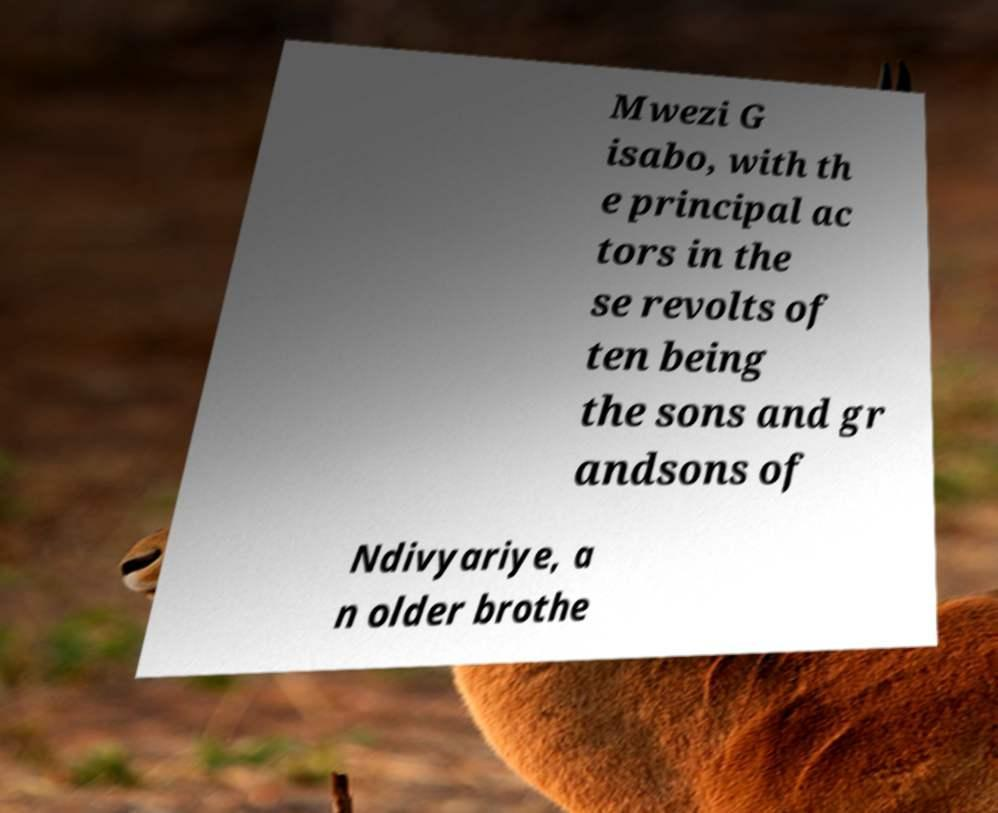Please read and relay the text visible in this image. What does it say? Mwezi G isabo, with th e principal ac tors in the se revolts of ten being the sons and gr andsons of Ndivyariye, a n older brothe 